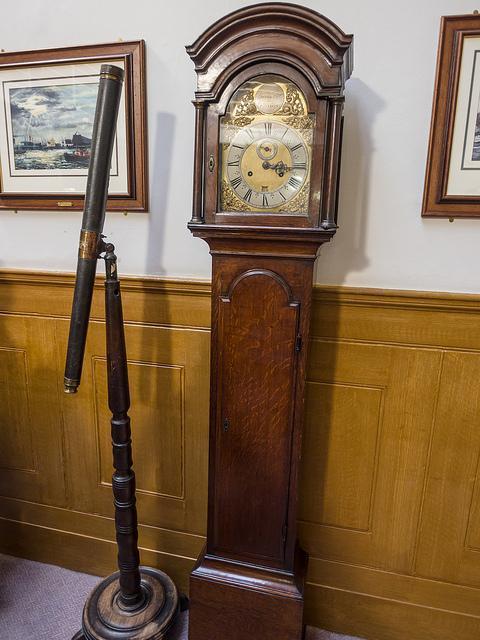How many pictures are in this photo?
Give a very brief answer. 2. 